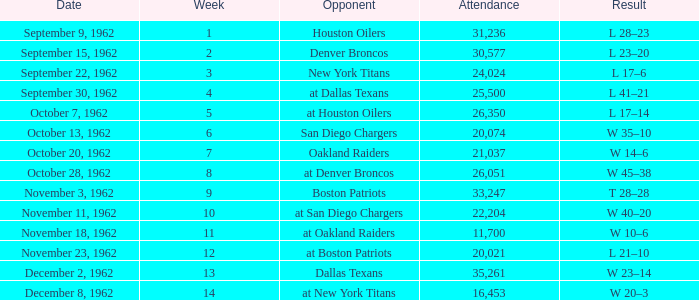What week was the attendance smaller than 22,204 on December 8, 1962? 14.0. Write the full table. {'header': ['Date', 'Week', 'Opponent', 'Attendance', 'Result'], 'rows': [['September 9, 1962', '1', 'Houston Oilers', '31,236', 'L 28–23'], ['September 15, 1962', '2', 'Denver Broncos', '30,577', 'L 23–20'], ['September 22, 1962', '3', 'New York Titans', '24,024', 'L 17–6'], ['September 30, 1962', '4', 'at Dallas Texans', '25,500', 'L 41–21'], ['October 7, 1962', '5', 'at Houston Oilers', '26,350', 'L 17–14'], ['October 13, 1962', '6', 'San Diego Chargers', '20,074', 'W 35–10'], ['October 20, 1962', '7', 'Oakland Raiders', '21,037', 'W 14–6'], ['October 28, 1962', '8', 'at Denver Broncos', '26,051', 'W 45–38'], ['November 3, 1962', '9', 'Boston Patriots', '33,247', 'T 28–28'], ['November 11, 1962', '10', 'at San Diego Chargers', '22,204', 'W 40–20'], ['November 18, 1962', '11', 'at Oakland Raiders', '11,700', 'W 10–6'], ['November 23, 1962', '12', 'at Boston Patriots', '20,021', 'L 21–10'], ['December 2, 1962', '13', 'Dallas Texans', '35,261', 'W 23–14'], ['December 8, 1962', '14', 'at New York Titans', '16,453', 'W 20–3']]} 